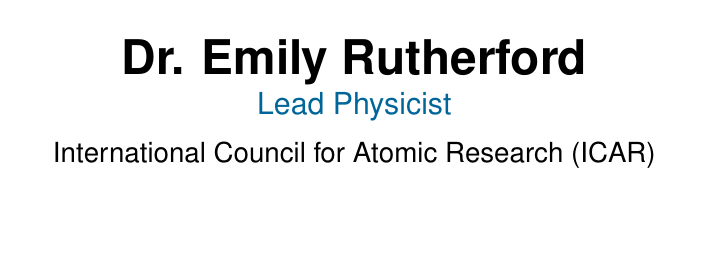What is the name of the lead physicist? The name listed on the business card is Dr. Emily Rutherford.
Answer: Dr. Emily Rutherford What organization is Dr. Emily affiliated with? The document states that she is affiliated with the International Council for Atomic Research (ICAR).
Answer: International Council for Atomic Research (ICAR) What is Dr. Emily's email address? The email provided on the business card is emily.rutherford@icar-research.org.
Answer: emily.rutherford@icar-research.org Which social media platform is linked to Dr. Emily? The business card features her LinkedIn and Twitter accounts.
Answer: LinkedIn and Twitter What is the theme of the collaboration mentioned? The card discusses collaboration on innovative nuclear fusion projects.
Answer: innovative nuclear fusion projects What type of energy is the focus of the projects? The collaboration aims to pioneer clean energy solutions.
Answer: clean energy What are two types of fusion research mentioned? The areas of research specified are Magnetic Confinement and Inertial Confinement.
Answer: Magnetic Confinement and Inertial Confinement What is the purpose of this document? The document serves as a professional invitation for collaboration on nuclear fusion projects.
Answer: professional invitation for collaboration 